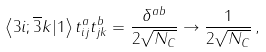<formula> <loc_0><loc_0><loc_500><loc_500>\left \langle 3 i ; \overline { 3 } k | 1 \right \rangle t ^ { a } _ { i j } t ^ { b } _ { j k } = \frac { \delta ^ { a b } } { 2 \sqrt { N _ { C } } } \to \frac { 1 } { 2 \sqrt { N _ { C } } } \, ,</formula> 